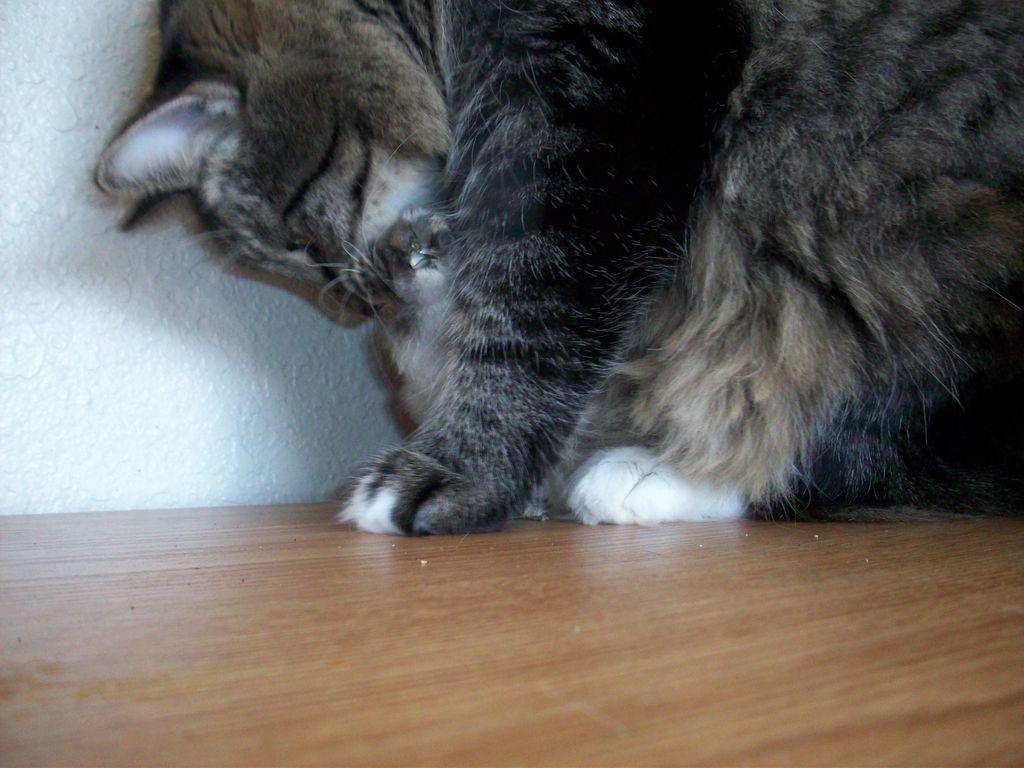Please provide a concise description of this image. In this image, I can see a cat on the wooden floor. In the background there is a wall. 